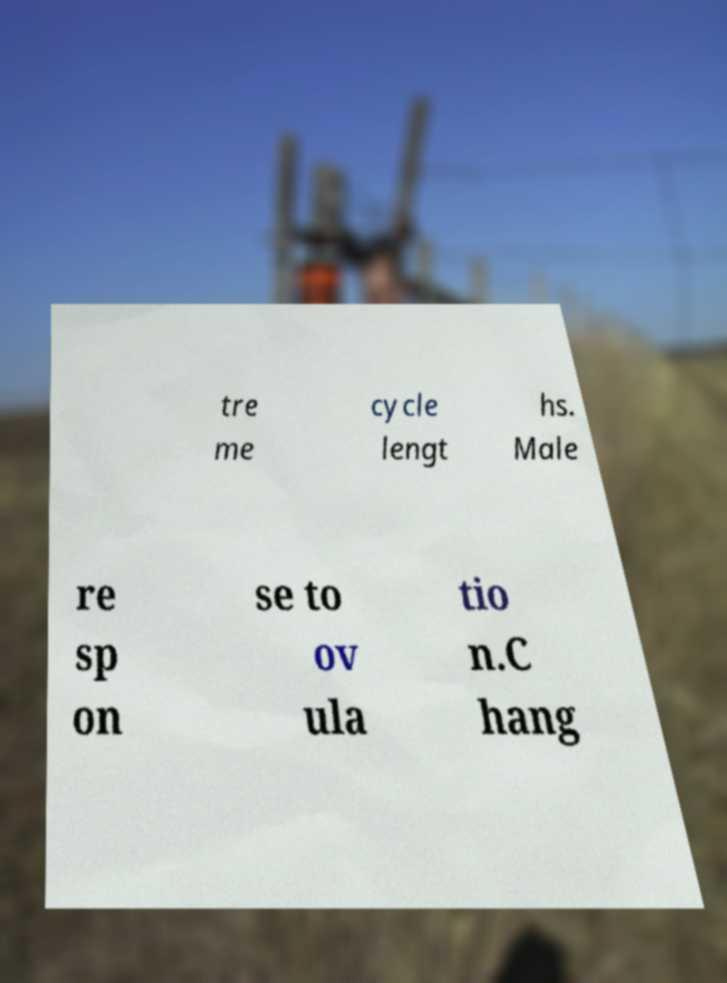Can you read and provide the text displayed in the image?This photo seems to have some interesting text. Can you extract and type it out for me? tre me cycle lengt hs. Male re sp on se to ov ula tio n.C hang 